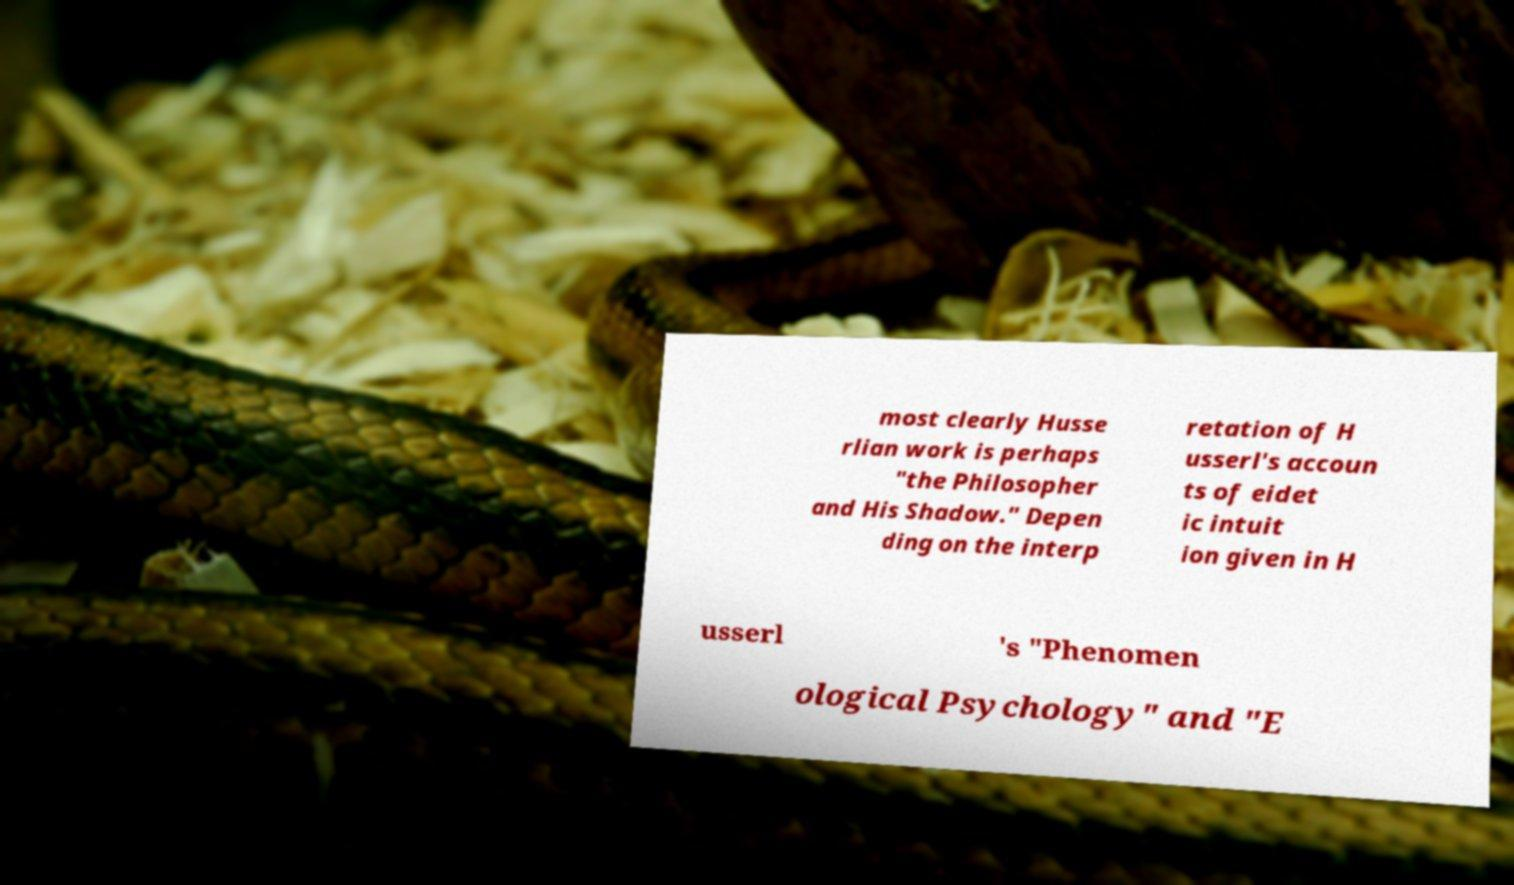For documentation purposes, I need the text within this image transcribed. Could you provide that? most clearly Husse rlian work is perhaps "the Philosopher and His Shadow." Depen ding on the interp retation of H usserl's accoun ts of eidet ic intuit ion given in H usserl 's "Phenomen ological Psychology" and "E 